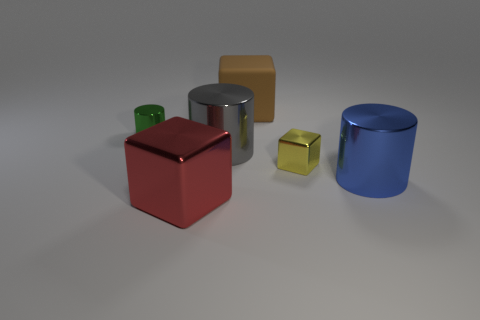Add 2 big red blocks. How many objects exist? 8 Subtract all big metal cubes. How many cubes are left? 2 Subtract 3 blocks. How many blocks are left? 0 Subtract all cyan balls. How many red cubes are left? 1 Subtract all big blue objects. Subtract all small green shiny cylinders. How many objects are left? 4 Add 5 blue cylinders. How many blue cylinders are left? 6 Add 3 metallic cubes. How many metallic cubes exist? 5 Subtract all red blocks. How many blocks are left? 2 Subtract 0 purple balls. How many objects are left? 6 Subtract all brown blocks. Subtract all blue balls. How many blocks are left? 2 